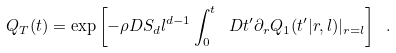<formula> <loc_0><loc_0><loc_500><loc_500>Q _ { T } ( t ) = \exp \left [ - \rho D S _ { d } l ^ { d - 1 } \int _ { 0 } ^ { t } \ D t ^ { \prime } \partial _ { r } Q _ { 1 } ( t ^ { \prime } | r , l ) | _ { r = l } \right ] \ .</formula> 